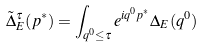Convert formula to latex. <formula><loc_0><loc_0><loc_500><loc_500>\tilde { \Delta } ^ { \tau } _ { E } ( p ^ { * } ) = \int _ { q ^ { 0 } \leq \tau } e ^ { i q ^ { 0 } p ^ { * } } \Delta _ { E } ( q ^ { 0 } )</formula> 